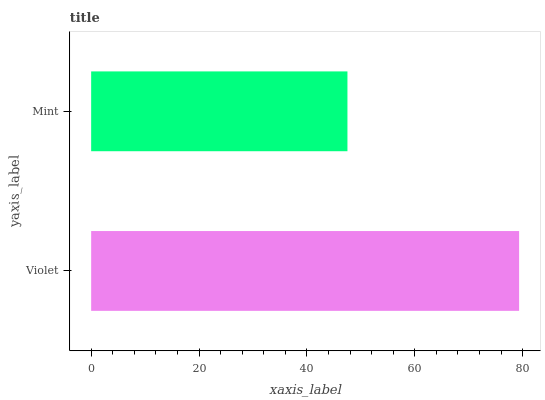Is Mint the minimum?
Answer yes or no. Yes. Is Violet the maximum?
Answer yes or no. Yes. Is Mint the maximum?
Answer yes or no. No. Is Violet greater than Mint?
Answer yes or no. Yes. Is Mint less than Violet?
Answer yes or no. Yes. Is Mint greater than Violet?
Answer yes or no. No. Is Violet less than Mint?
Answer yes or no. No. Is Violet the high median?
Answer yes or no. Yes. Is Mint the low median?
Answer yes or no. Yes. Is Mint the high median?
Answer yes or no. No. Is Violet the low median?
Answer yes or no. No. 